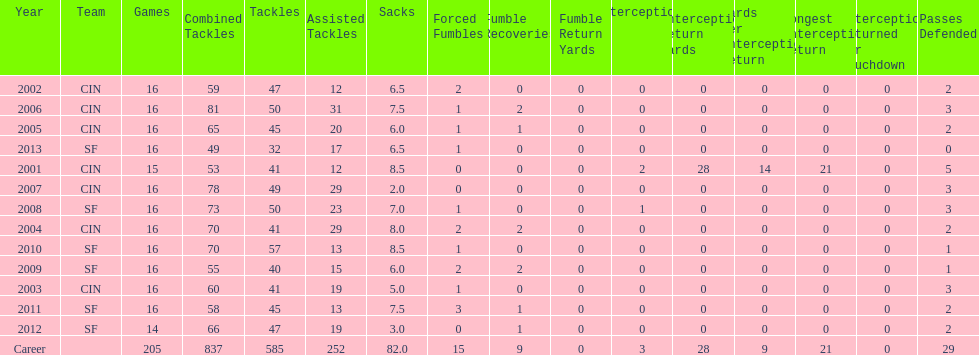What is the mean number of tackles this player has had throughout his career? 45. 